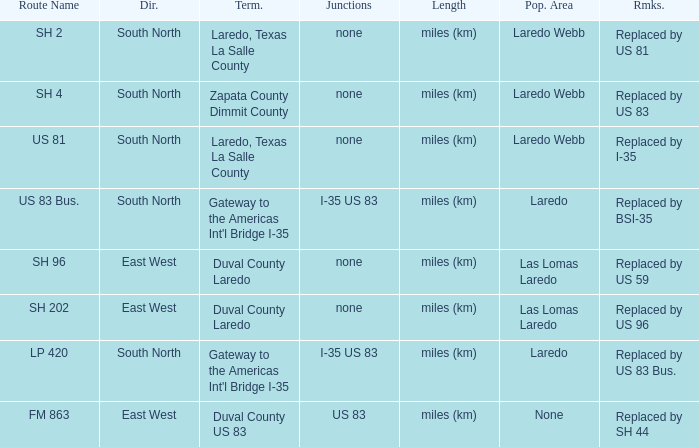Which population areas have "replaced by us 83" listed in their remarks section? Laredo Webb. 